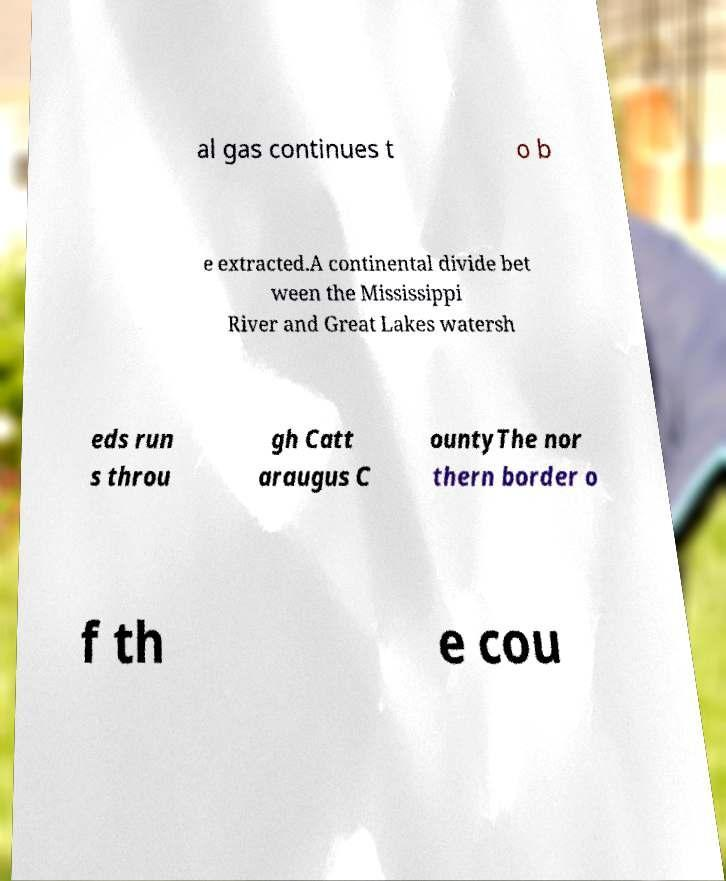Could you assist in decoding the text presented in this image and type it out clearly? al gas continues t o b e extracted.A continental divide bet ween the Mississippi River and Great Lakes watersh eds run s throu gh Catt araugus C ountyThe nor thern border o f th e cou 